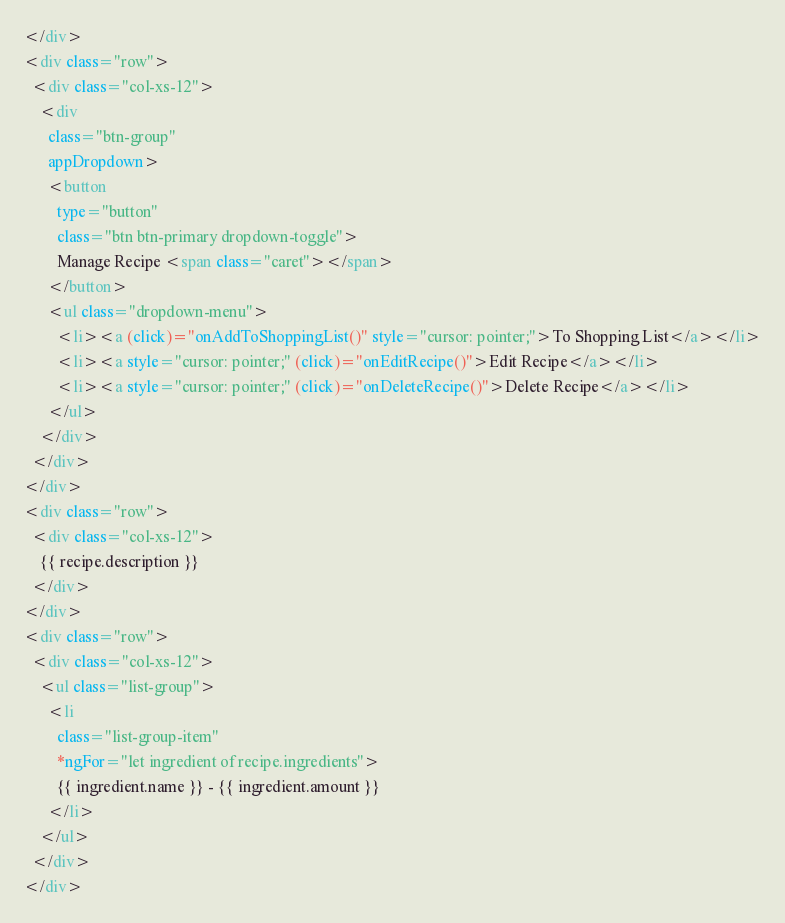<code> <loc_0><loc_0><loc_500><loc_500><_HTML_></div>
<div class="row">
  <div class="col-xs-12">
    <div
      class="btn-group"
      appDropdown>
      <button
        type="button"
        class="btn btn-primary dropdown-toggle">
        Manage Recipe <span class="caret"></span>
      </button>
      <ul class="dropdown-menu">
        <li><a (click)="onAddToShoppingList()" style="cursor: pointer;">To Shopping List</a></li>
        <li><a style="cursor: pointer;" (click)="onEditRecipe()">Edit Recipe</a></li>
        <li><a style="cursor: pointer;" (click)="onDeleteRecipe()">Delete Recipe</a></li>
      </ul>
    </div>
  </div>
</div>
<div class="row">
  <div class="col-xs-12">
    {{ recipe.description }}
  </div>
</div>
<div class="row">
  <div class="col-xs-12">
    <ul class="list-group">
      <li
        class="list-group-item"
        *ngFor="let ingredient of recipe.ingredients">
        {{ ingredient.name }} - {{ ingredient.amount }}
      </li>
    </ul>
  </div>
</div>
</code> 